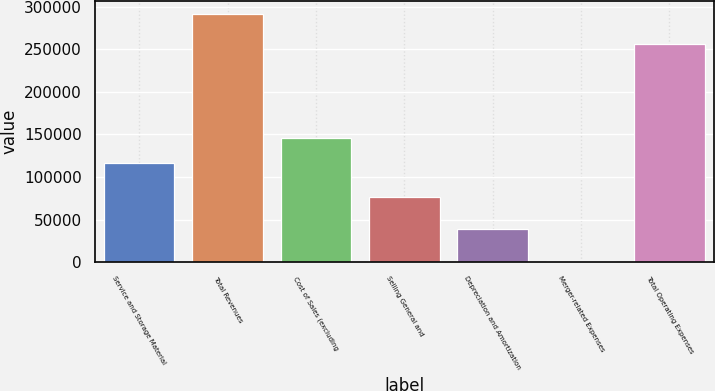Convert chart. <chart><loc_0><loc_0><loc_500><loc_500><bar_chart><fcel>Service and Storage Material<fcel>Total Revenues<fcel>Cost of Sales (excluding<fcel>Selling General and<fcel>Depreciation and Amortization<fcel>Merger-related Expenses<fcel>Total Operating Expenses<nl><fcel>116661<fcel>291673<fcel>145723<fcel>76822<fcel>38921<fcel>1049<fcel>256710<nl></chart> 